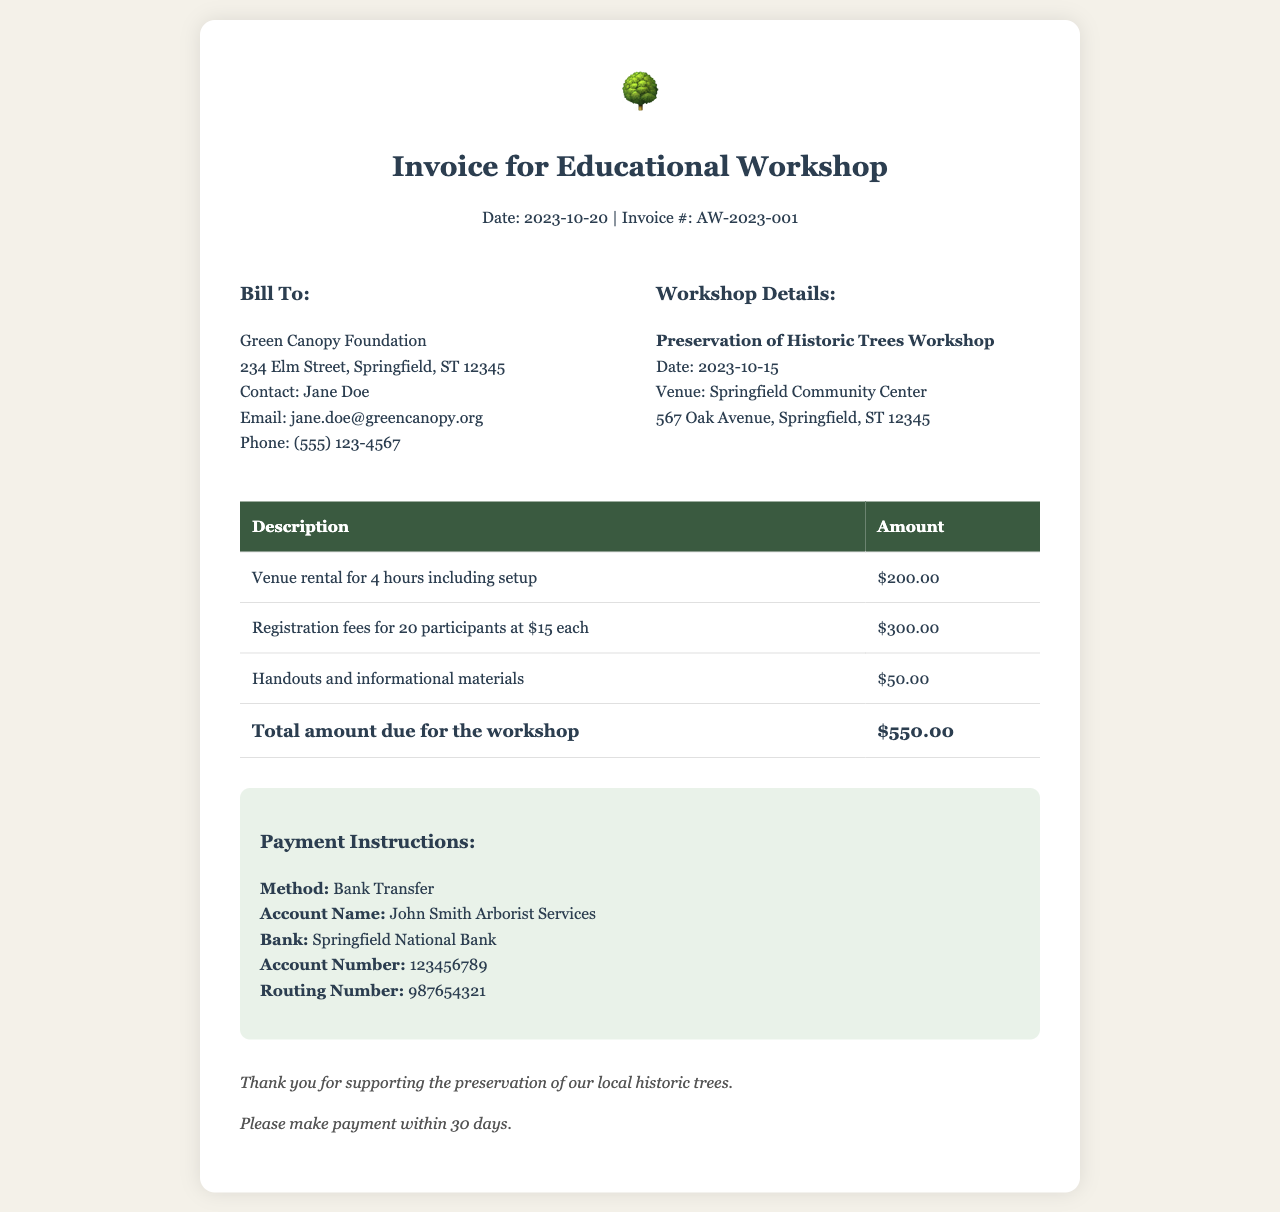What is the total amount due for the workshop? The total amount due is shown at the bottom of the invoice, which sums all listed charges.
Answer: $550.00 Who is the contact person for the Green Canopy Foundation? The contact person is mentioned in the billing section of the invoice.
Answer: Jane Doe What is the venue for the workshop? The venue name is specified in the workshop details section.
Answer: Springfield Community Center How many participants registered for the workshop? The number of participants is indicated in the registration fees description on the invoice.
Answer: 20 What is the date of the workshop? The date of the workshop is stated clearly in the workshop details section.
Answer: 2023-10-15 What is the amount for the venue rental? The venue rental amount is provided in the description of the invoice.
Answer: $200.00 What payment method is preferred for the invoice? The payment method is outlined under the payment instructions section.
Answer: Bank Transfer What type of materials were provided for the workshop? The type of materials is described in one of the charge descriptions in the invoice.
Answer: Handouts and informational materials 